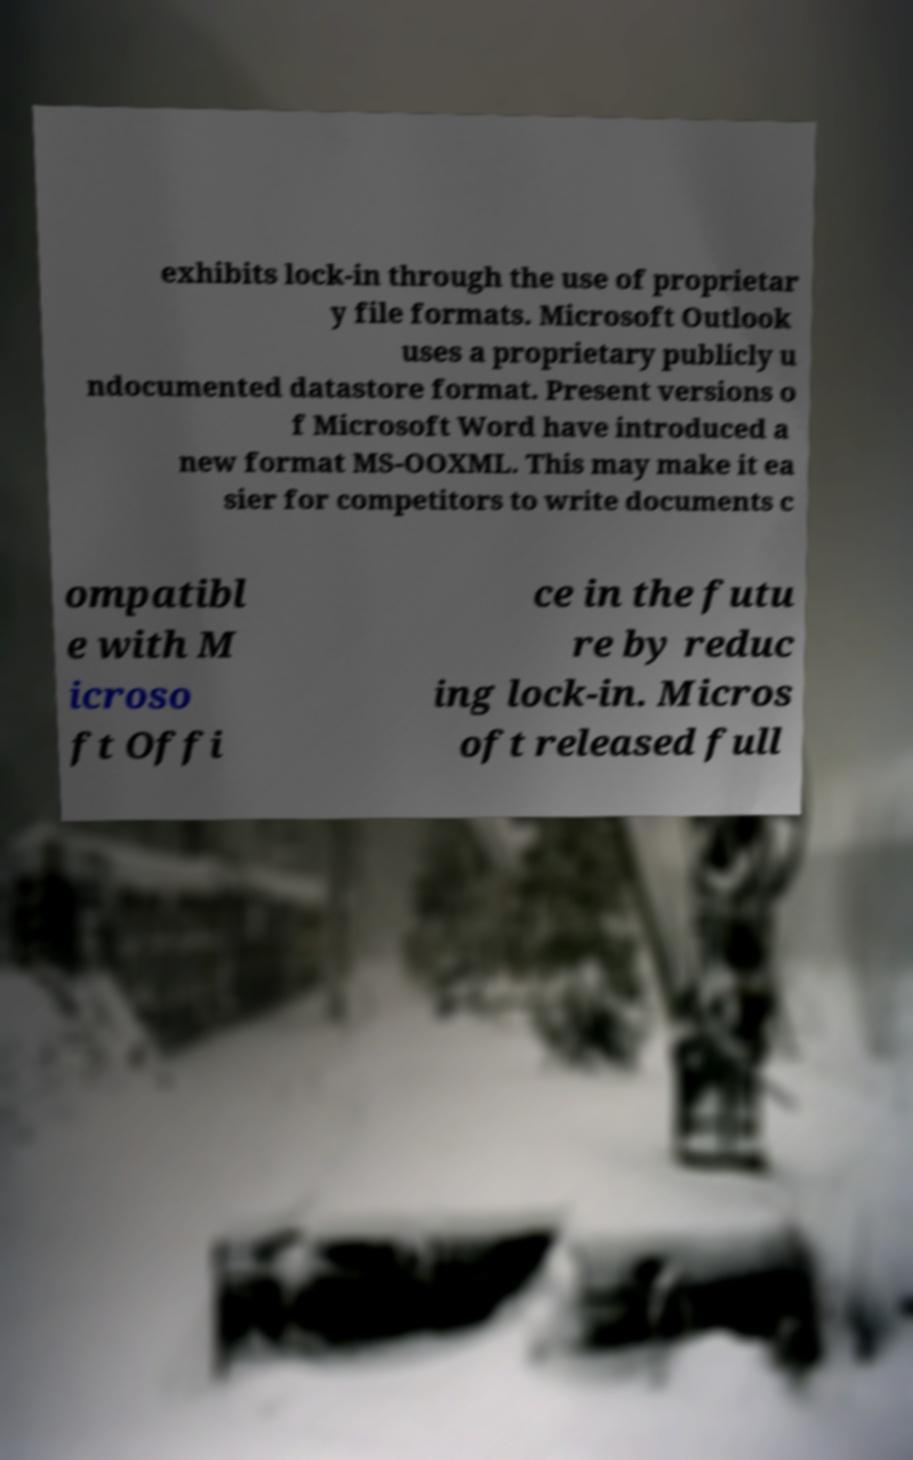Can you accurately transcribe the text from the provided image for me? exhibits lock-in through the use of proprietar y file formats. Microsoft Outlook uses a proprietary publicly u ndocumented datastore format. Present versions o f Microsoft Word have introduced a new format MS-OOXML. This may make it ea sier for competitors to write documents c ompatibl e with M icroso ft Offi ce in the futu re by reduc ing lock-in. Micros oft released full 